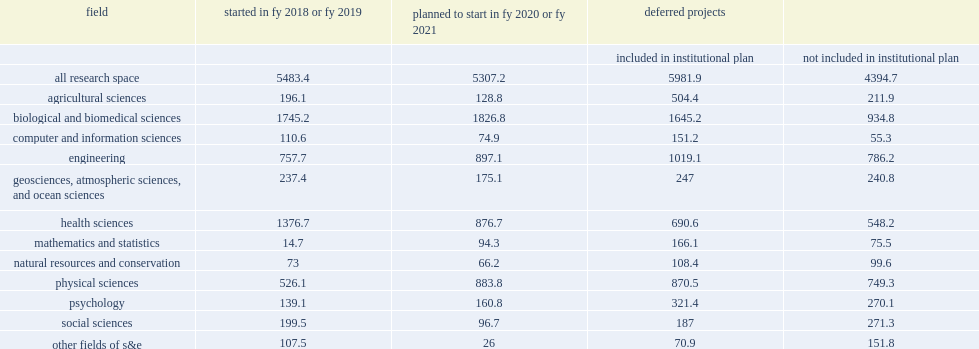How many million dollars did academic institutions expend on major repairs and renovation of s&e research space started in fy 2018 or fy 2019? 5483.4. What was the costs for repair and renovations started in fys 2018-19 for engineering? 757.7. What was the costs for repair and renovations started in fys 2018-19 for physical sciences research space? 526.1. How many million dollars do institutions anticipate in costs for planned repairs and renovations with start dates in fy 2020 or fy 2021? 5307.2. How many million dollars do they expect to spend improving research space in biological and biomedical sciences in fy 2020 or fy 2021? 1826.8. 